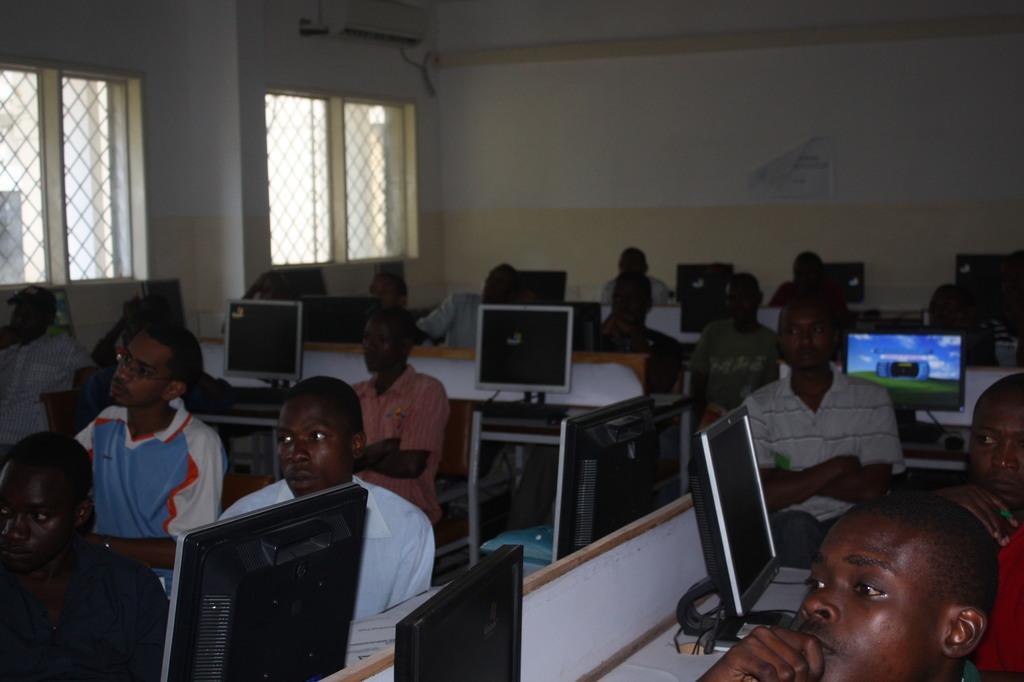Can you describe this image briefly? In this image we can see people are sitting on the chairs. There are tables, monitors, and few objects. In the background we can see windows, poster, and wall. 